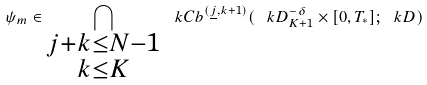<formula> <loc_0><loc_0><loc_500><loc_500>\psi _ { m } \in \bigcap _ { \substack { j + k \leq N - 1 \\ k \leq K } } \ k C b ^ { ( \underline { j } , k + 1 ) } ( \ k D _ { K + 1 } ^ { - \delta } \times [ 0 , T _ { * } ] ; \ k D )</formula> 